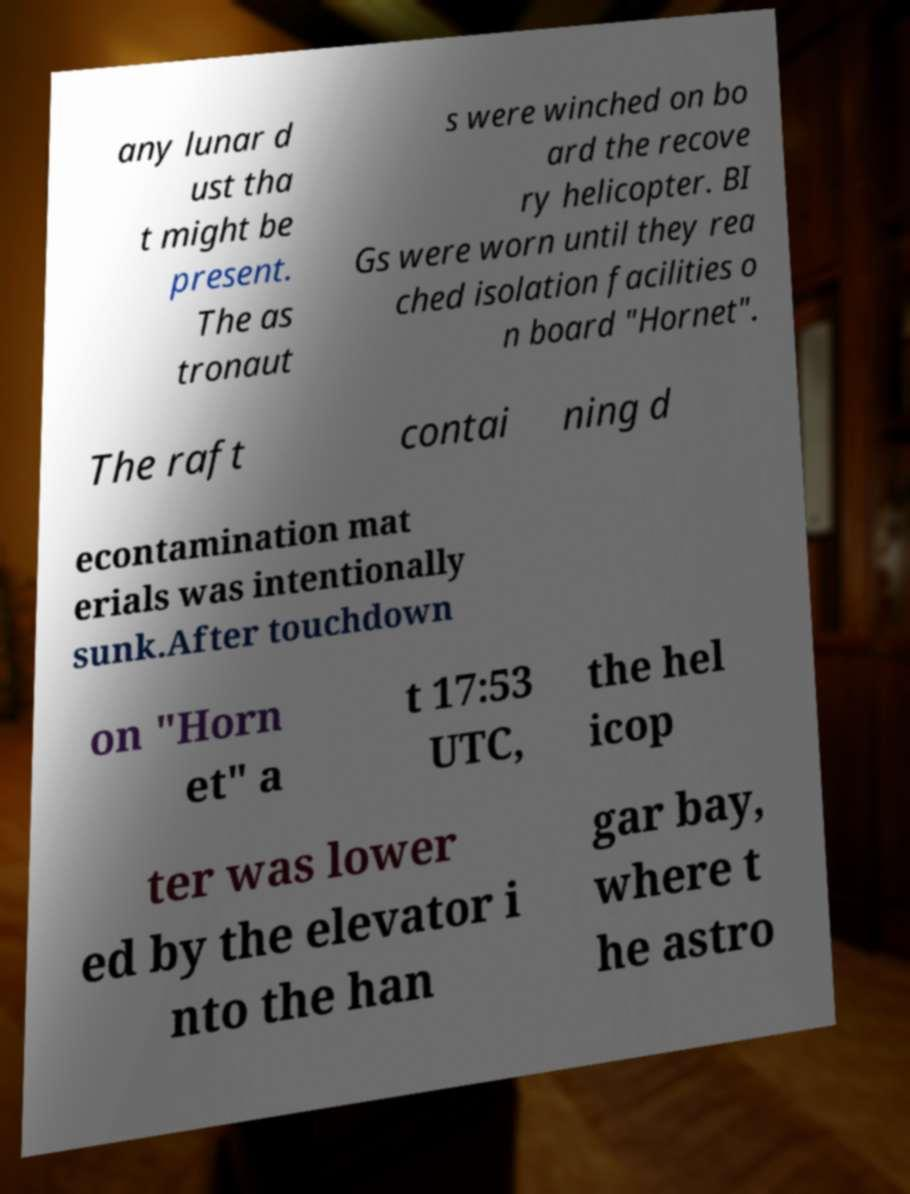Please read and relay the text visible in this image. What does it say? any lunar d ust tha t might be present. The as tronaut s were winched on bo ard the recove ry helicopter. BI Gs were worn until they rea ched isolation facilities o n board "Hornet". The raft contai ning d econtamination mat erials was intentionally sunk.After touchdown on "Horn et" a t 17:53 UTC, the hel icop ter was lower ed by the elevator i nto the han gar bay, where t he astro 